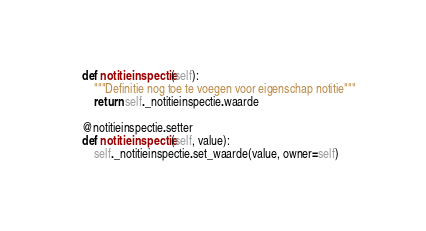Convert code to text. <code><loc_0><loc_0><loc_500><loc_500><_Python_>    def notitieinspectie(self):
        """Definitie nog toe te voegen voor eigenschap notitie"""
        return self._notitieinspectie.waarde

    @notitieinspectie.setter
    def notitieinspectie(self, value):
        self._notitieinspectie.set_waarde(value, owner=self)

</code> 